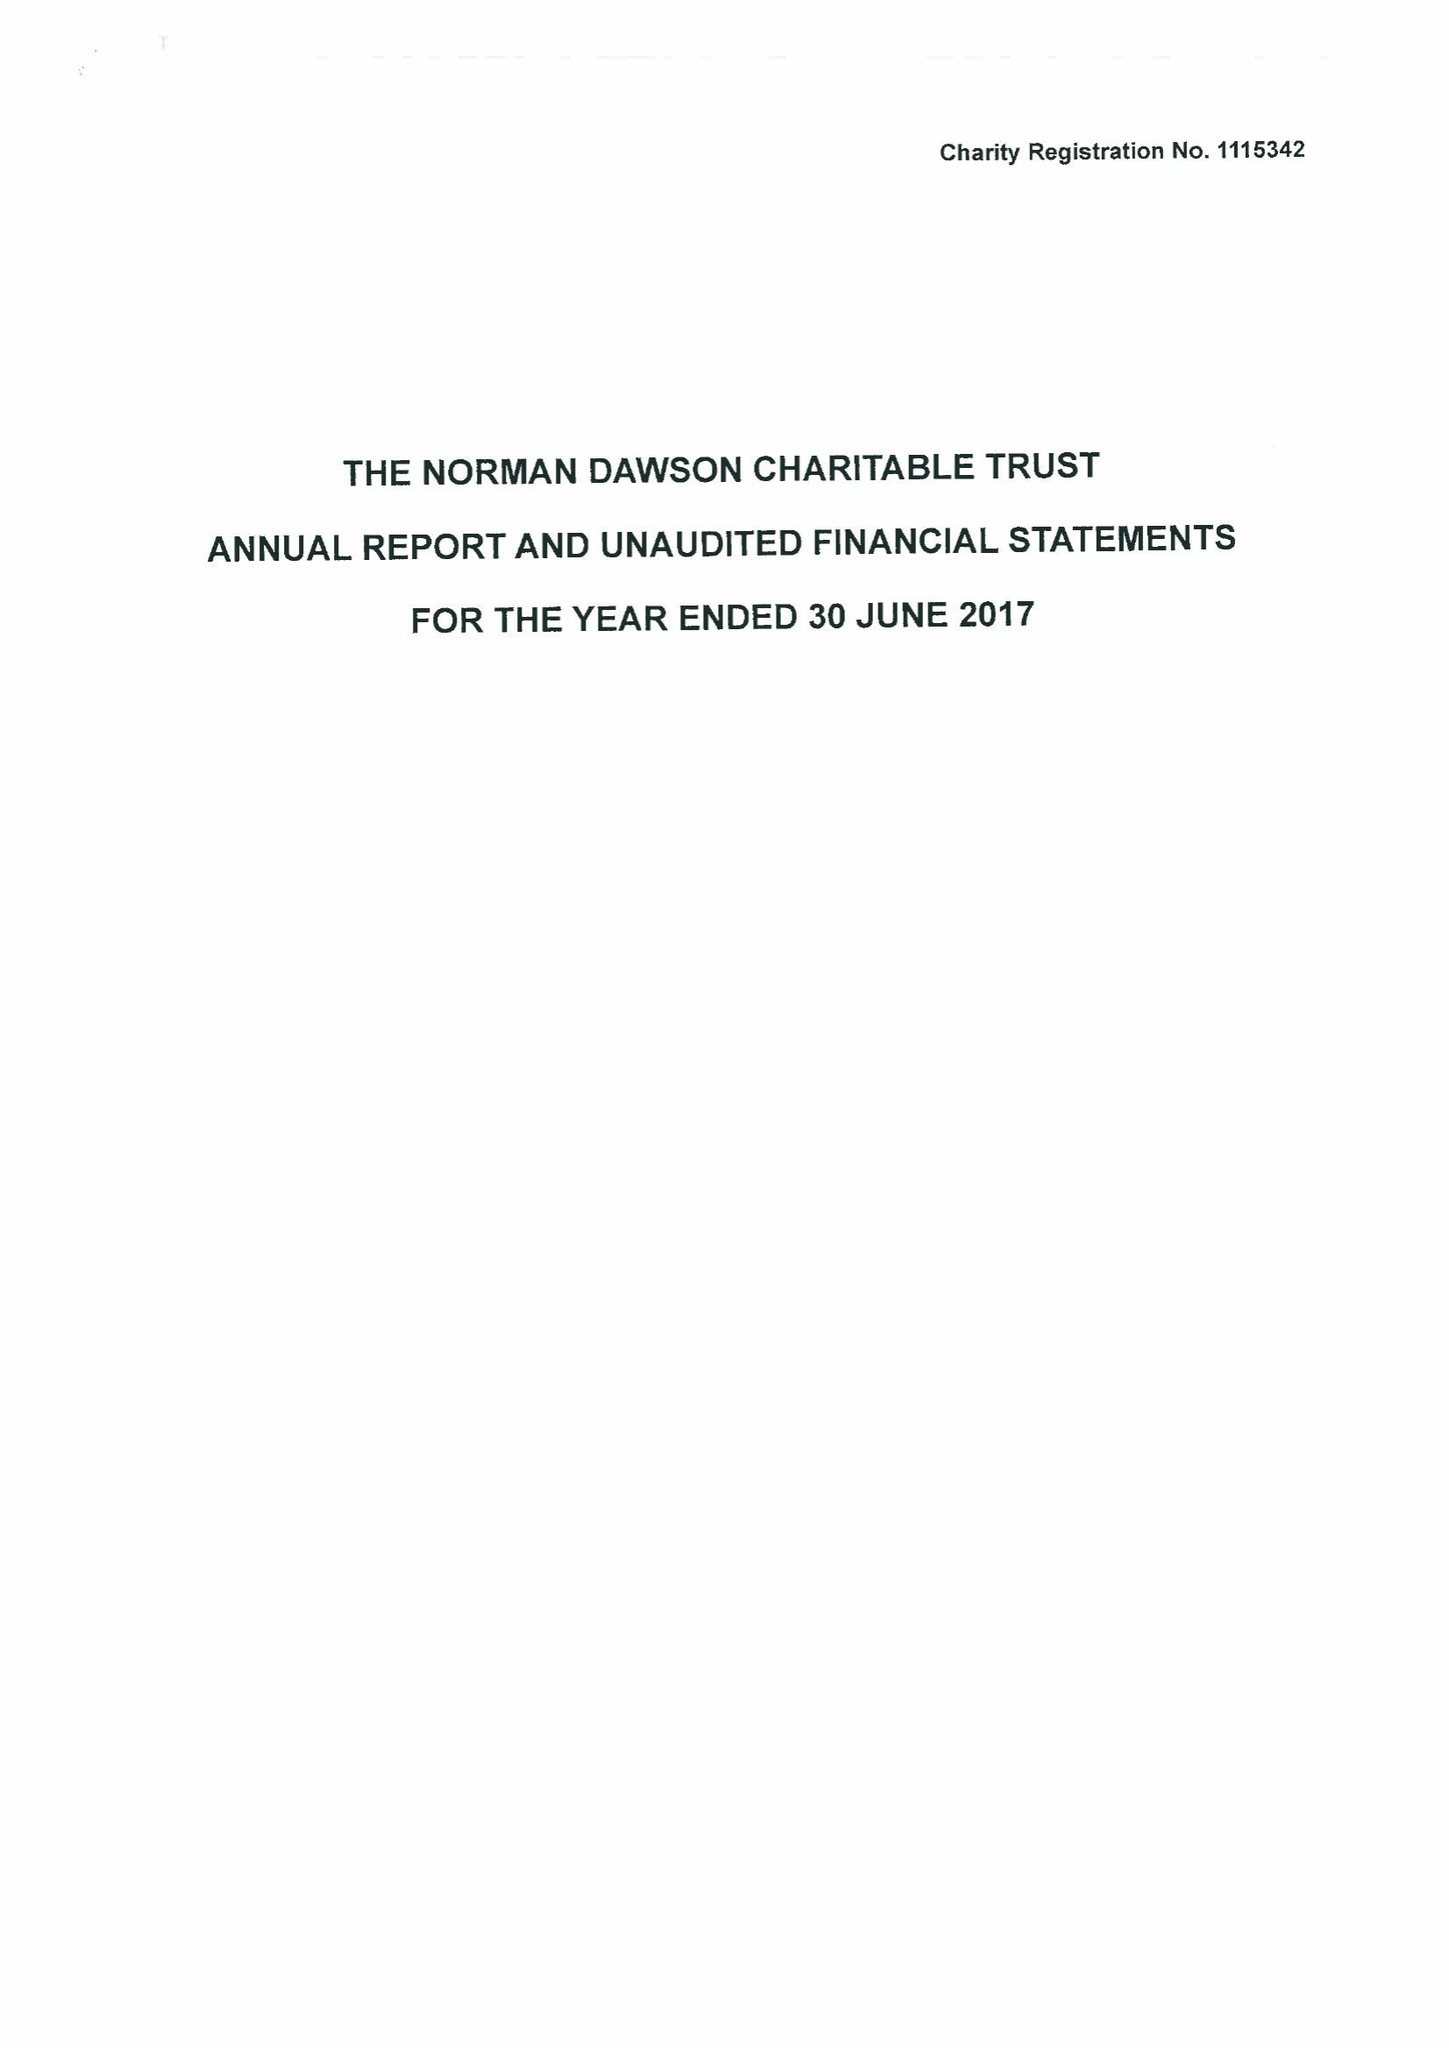What is the value for the address__street_line?
Answer the question using a single word or phrase. BIRMINGHAM ROAD 